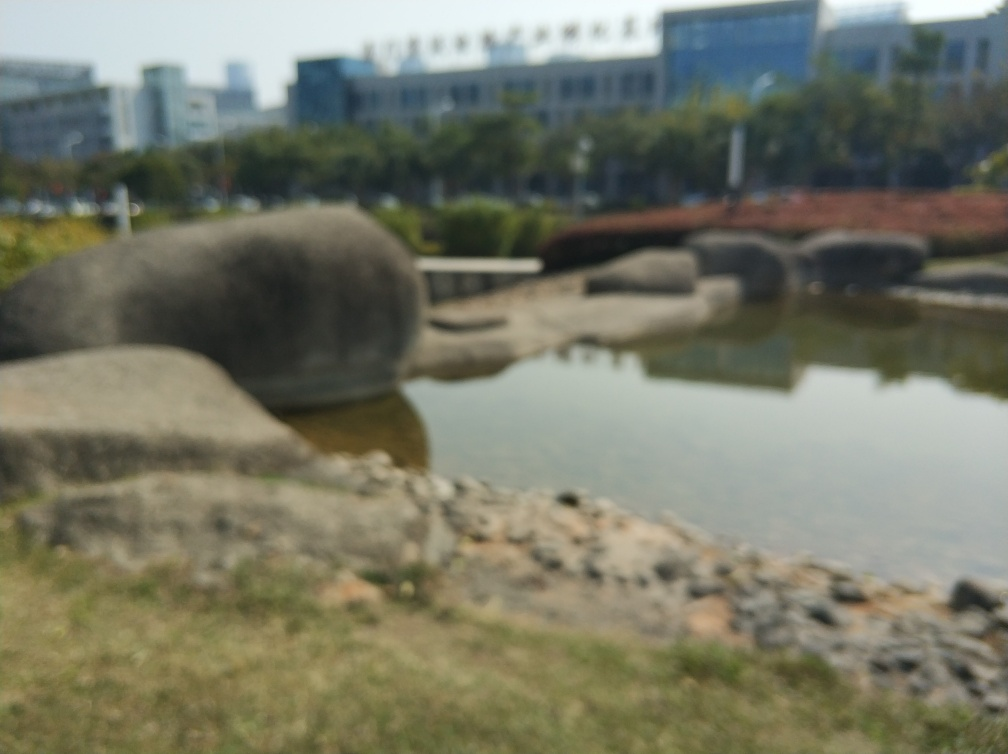Can you tell what time of day the photo was taken? Although the picture is out of focus, the quality of the ambient light suggests it may have been taken during daytime, possibly late morning or early afternoon based on the brightness and the lack of long shadows. 